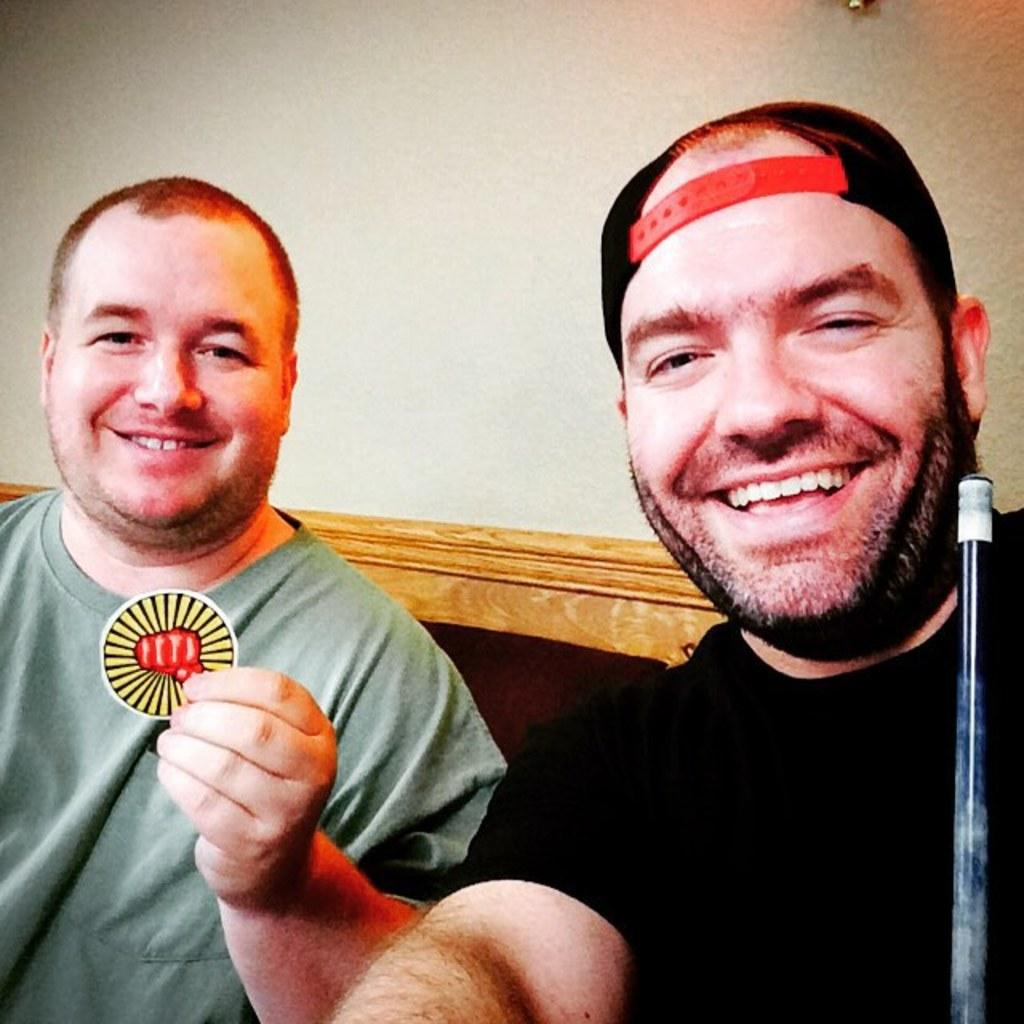How many people are in the image? There are two persons sitting in the center of the image. What can be seen in the background of the image? There is a wall in the background of the image. What shape is the cream on the person's eye in the image? There is no cream or eye present in the image; it only features two persons sitting in the center and a wall in the background. 